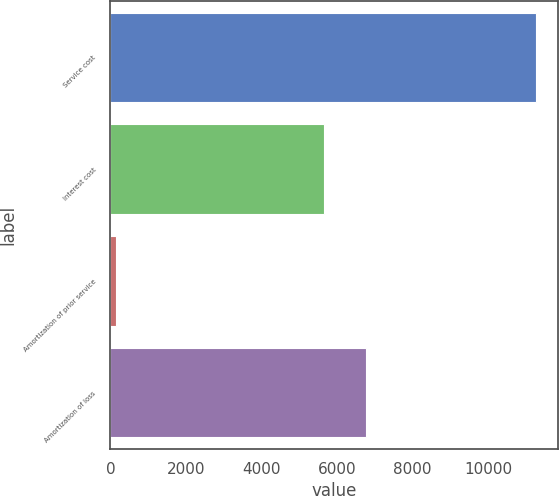<chart> <loc_0><loc_0><loc_500><loc_500><bar_chart><fcel>Service cost<fcel>Interest cost<fcel>Amortization of prior service<fcel>Amortization of loss<nl><fcel>11276<fcel>5643<fcel>159<fcel>6754.7<nl></chart> 